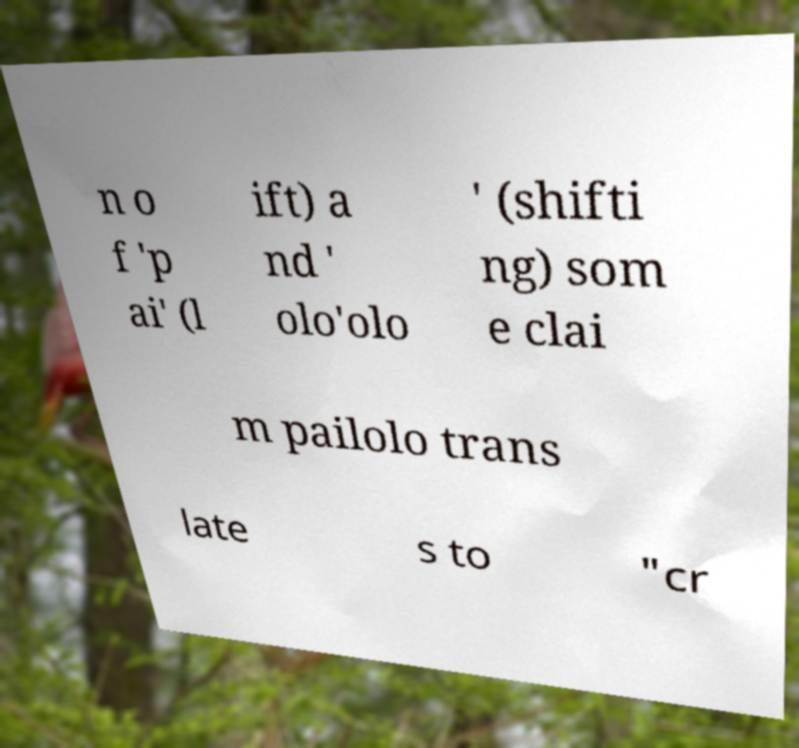Could you assist in decoding the text presented in this image and type it out clearly? n o f 'p ai' (l ift) a nd ' olo'olo ' (shifti ng) som e clai m pailolo trans late s to "cr 